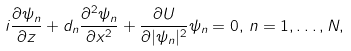Convert formula to latex. <formula><loc_0><loc_0><loc_500><loc_500>i \frac { \partial \psi _ { n } } { \partial z } + d _ { n } \frac { \partial ^ { 2 } \psi _ { n } } { \partial x ^ { 2 } } + \frac { \partial U } { \partial | \psi _ { n } | ^ { 2 } } \psi _ { n } = 0 , \, n = 1 , \dots , N ,</formula> 